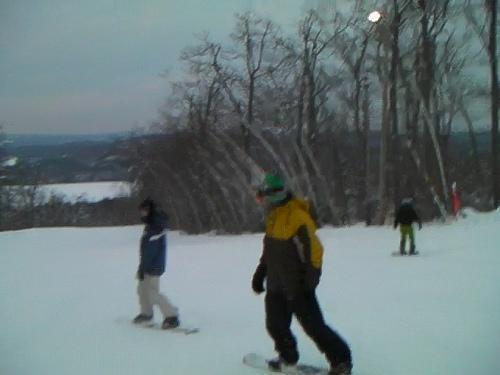Where does the white light come from?
Indicate the correct response by choosing from the four available options to answer the question.
Options: Sun, lamp, star, moon. Lamp. What does the white light come from?
Select the accurate answer and provide justification: `Answer: choice
Rationale: srationale.`
Options: Star, lamp, moon, sun. Answer: lamp.
Rationale: There is a light in the sky that is illuminating the area. 